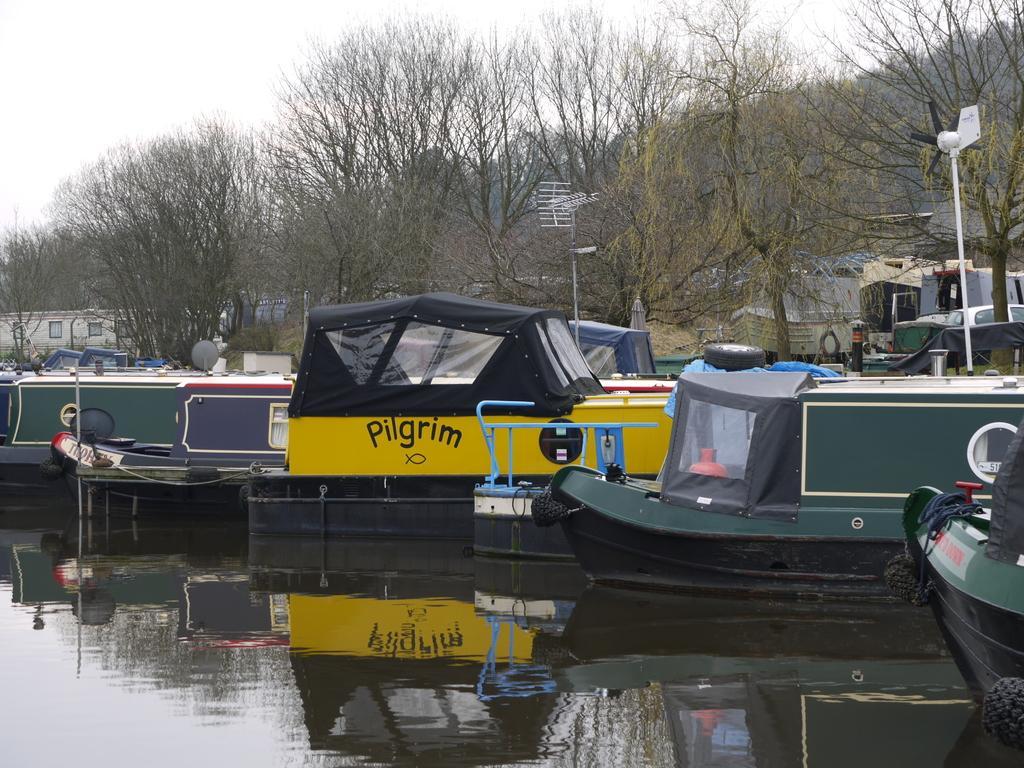How would you summarize this image in a sentence or two? This image consists of boats in the middle. There is water at the bottom. There are trees in the middle. There is sky at the top. 